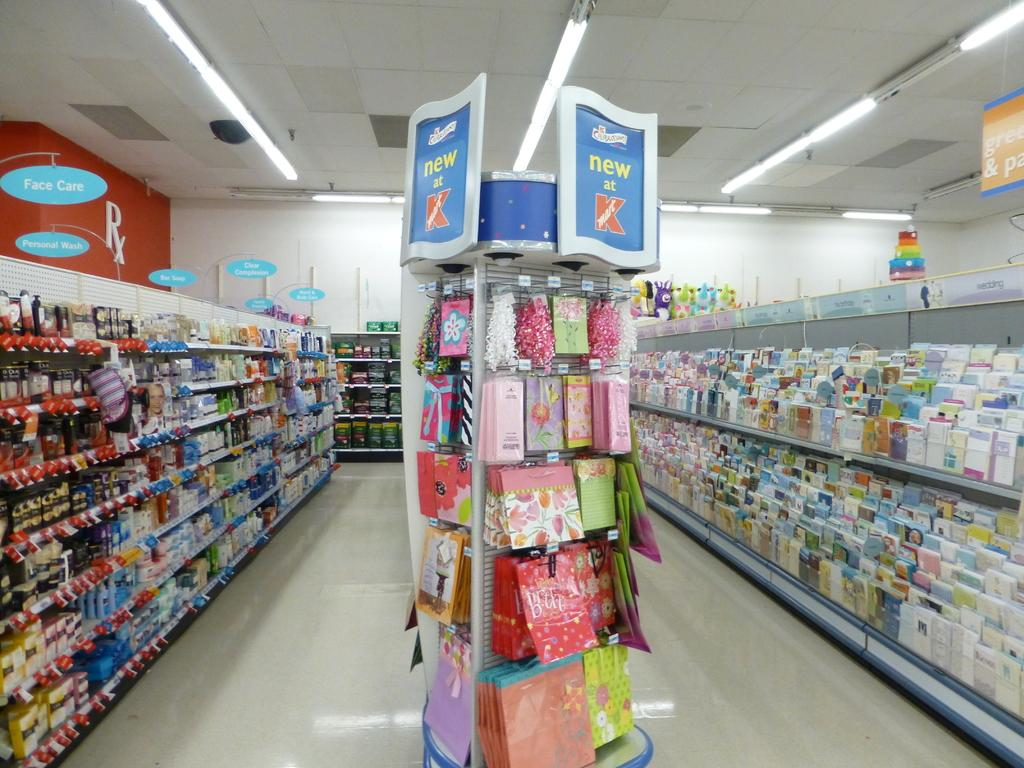<image>
Describe the image concisely. the inside of a store with a sign above an aisle that says 'new at kmart' on it 